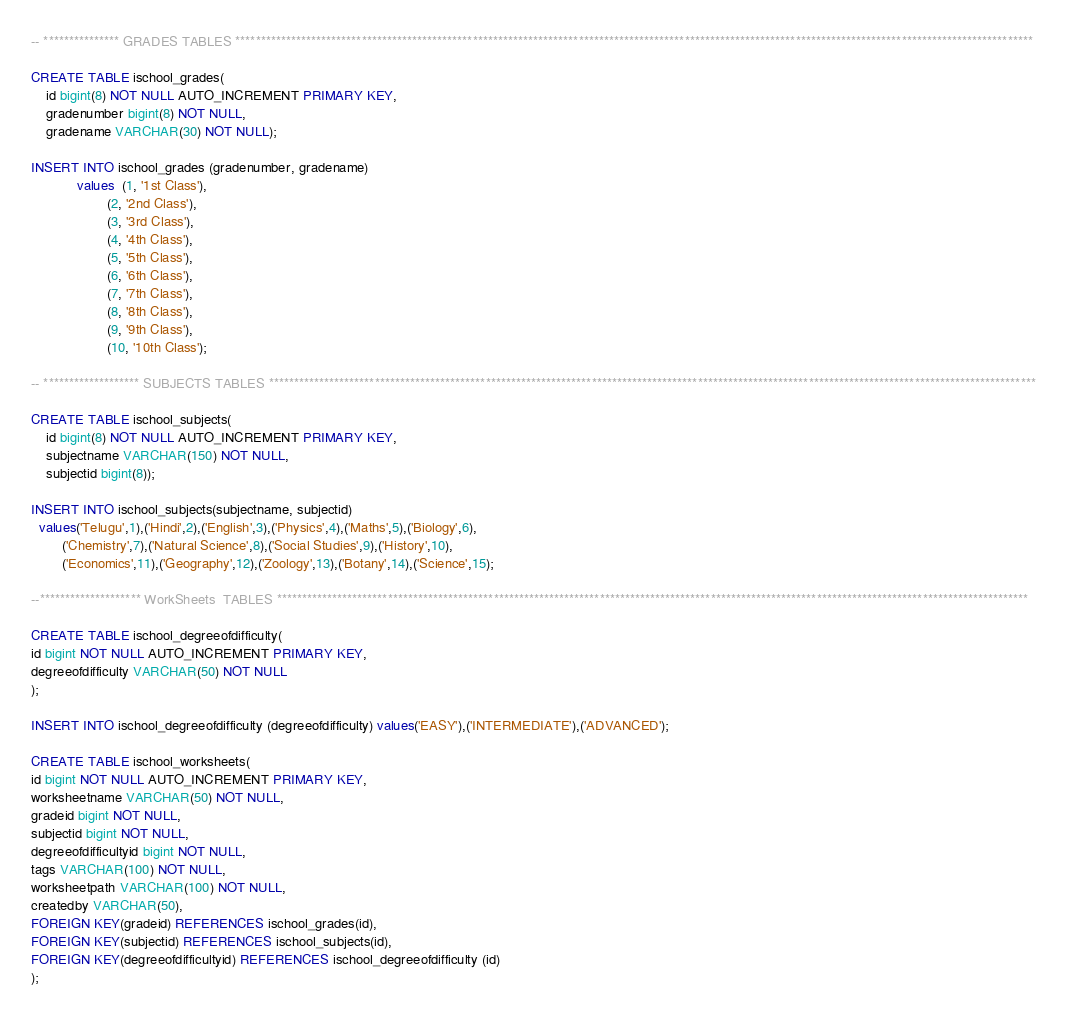Convert code to text. <code><loc_0><loc_0><loc_500><loc_500><_SQL_>-- *************** GRADES TABLES **************************************************************************************************************************************************************

CREATE TABLE ischool_grades(
	id bigint(8) NOT NULL AUTO_INCREMENT PRIMARY KEY,
	gradenumber bigint(8) NOT NULL,
	gradename VARCHAR(30) NOT NULL);

INSERT INTO ischool_grades (gradenumber, gradename)
			values  (1, '1st Class'),
					(2, '2nd Class'),
					(3, '3rd Class'),
					(4, '4th Class'),
					(5, '5th Class'),
					(6, '6th Class'),
					(7, '7th Class'),
					(8, '8th Class'),
					(9, '9th Class'),
				    (10, '10th Class');

-- ******************* SUBJECTS TABLES ********************************************************************************************************************************************************

CREATE TABLE ischool_subjects(
	id bigint(8) NOT NULL AUTO_INCREMENT PRIMARY KEY, 
	subjectname VARCHAR(150) NOT NULL,
	subjectid bigint(8));

INSERT INTO ischool_subjects(subjectname, subjectid) 
  values('Telugu',1),('Hindi',2),('English',3),('Physics',4),('Maths',5),('Biology',6),
		('Chemistry',7),('Natural Science',8),('Social Studies',9),('History',10),
		('Economics',11),('Geography',12),('Zoology',13),('Botany',14),('Science',15);

--******************** WorkSheets  TABLES *****************************************************************************************************************************************************

CREATE TABLE ischool_degreeofdifficulty(
id bigint NOT NULL AUTO_INCREMENT PRIMARY KEY,
degreeofdifficulty VARCHAR(50) NOT NULL
);

INSERT INTO ischool_degreeofdifficulty (degreeofdifficulty) values('EASY'),('INTERMEDIATE'),('ADVANCED');

CREATE TABLE ischool_worksheets(
id bigint NOT NULL AUTO_INCREMENT PRIMARY KEY,
worksheetname VARCHAR(50) NOT NULL,
gradeid bigint NOT NULL,
subjectid bigint NOT NULL,
degreeofdifficultyid bigint NOT NULL,
tags VARCHAR(100) NOT NULL,
worksheetpath VARCHAR(100) NOT NULL,
createdby VARCHAR(50),
FOREIGN KEY(gradeid) REFERENCES ischool_grades(id),
FOREIGN KEY(subjectid) REFERENCES ischool_subjects(id),
FOREIGN KEY(degreeofdifficultyid) REFERENCES ischool_degreeofdifficulty (id)
); 
</code> 